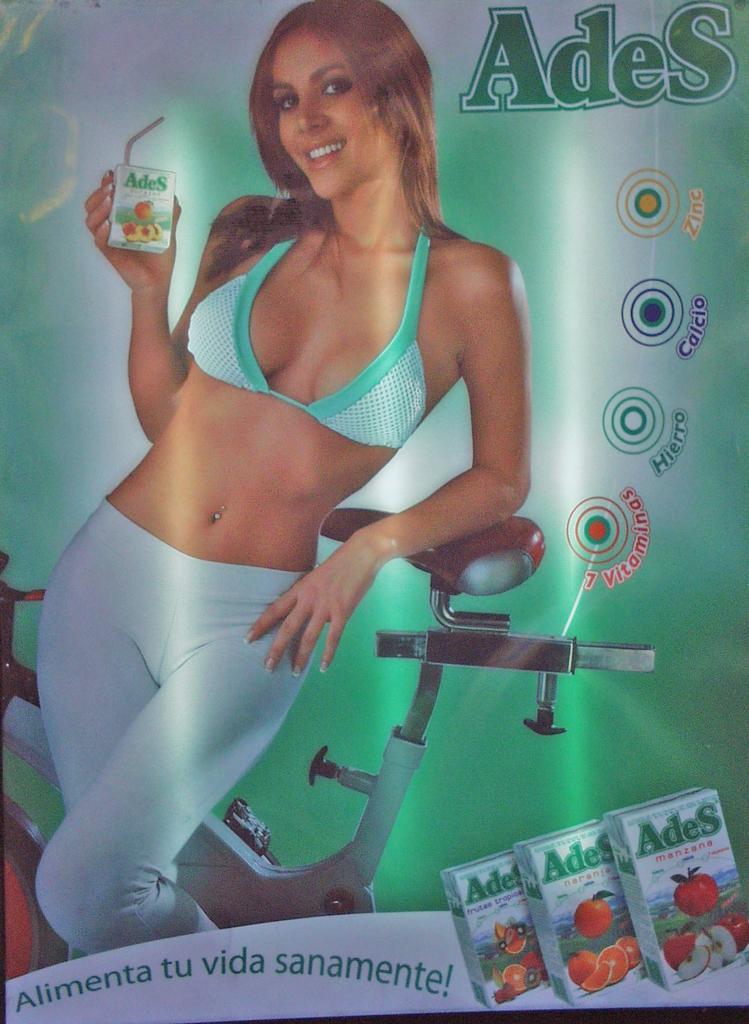Please provide a concise description of this image. In the image we can see a woman in the screen. 